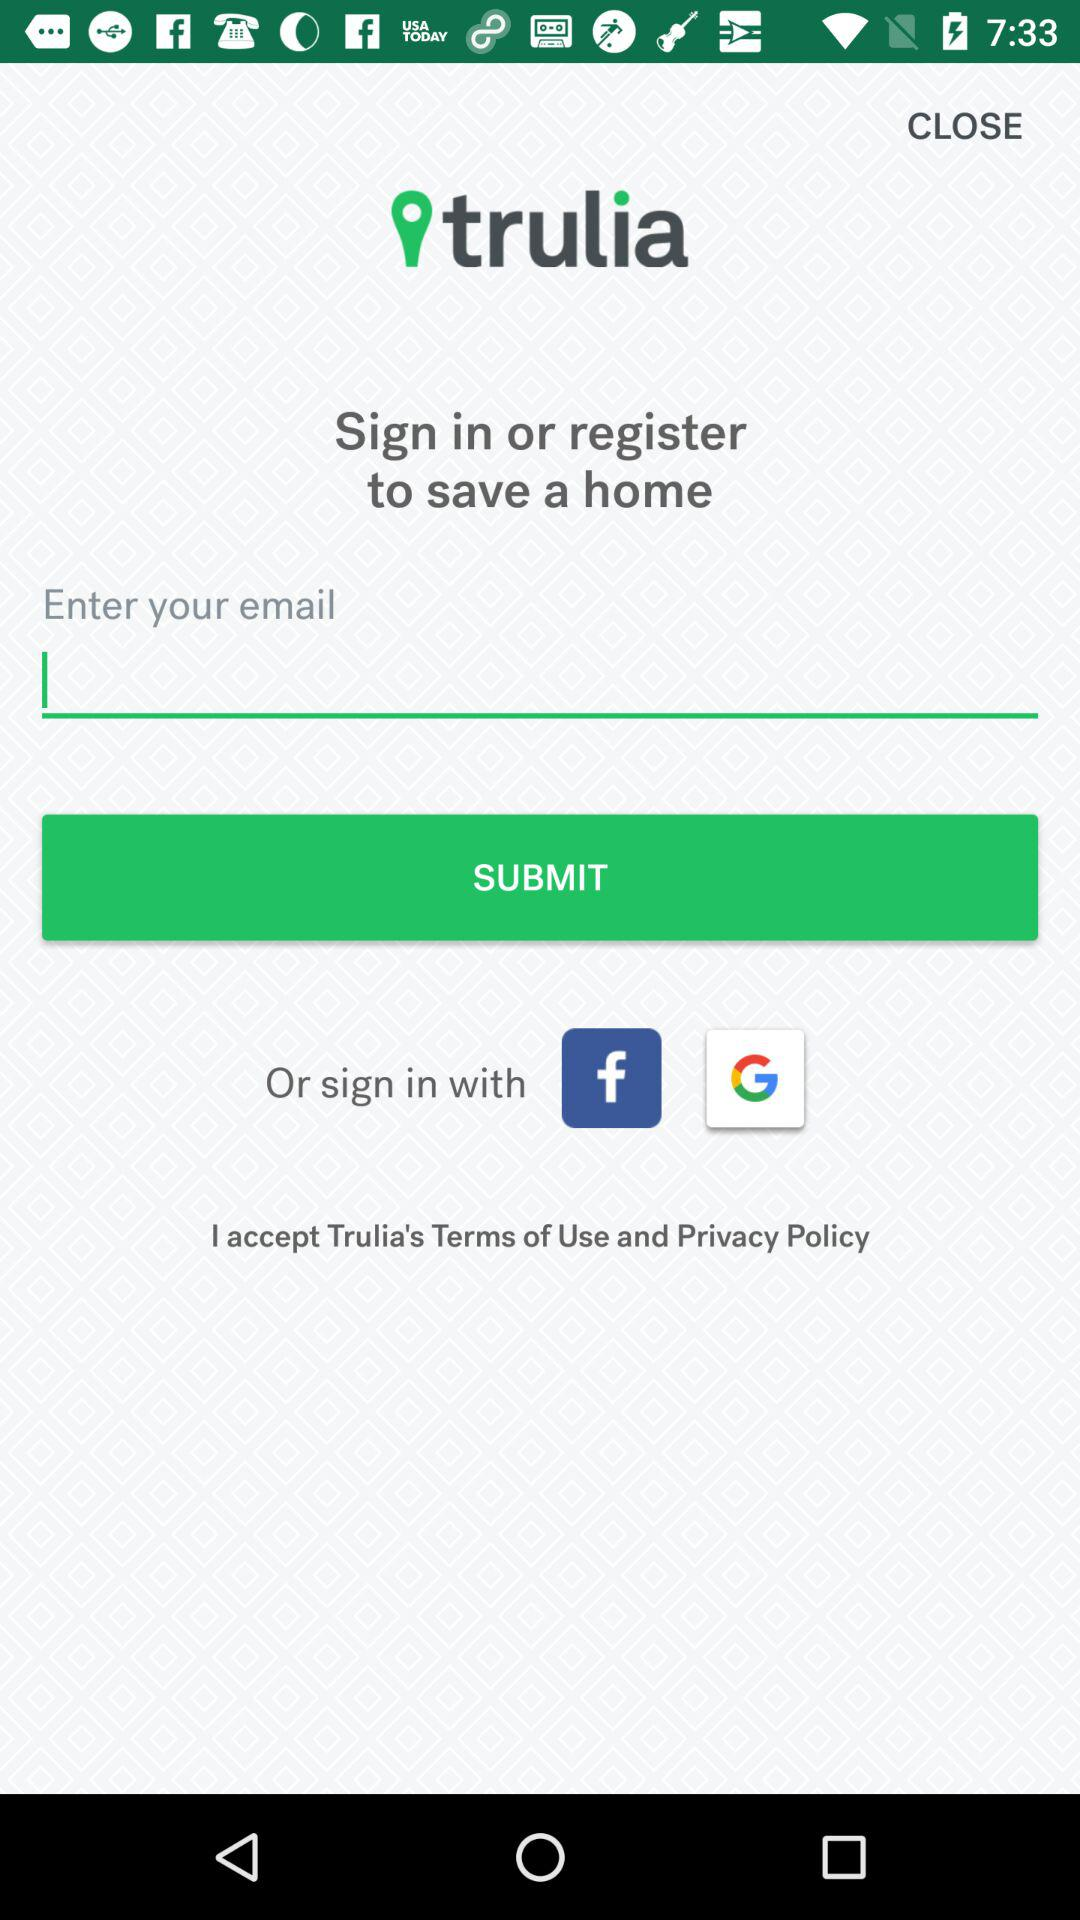What is the app name? The app name is "trulia". 